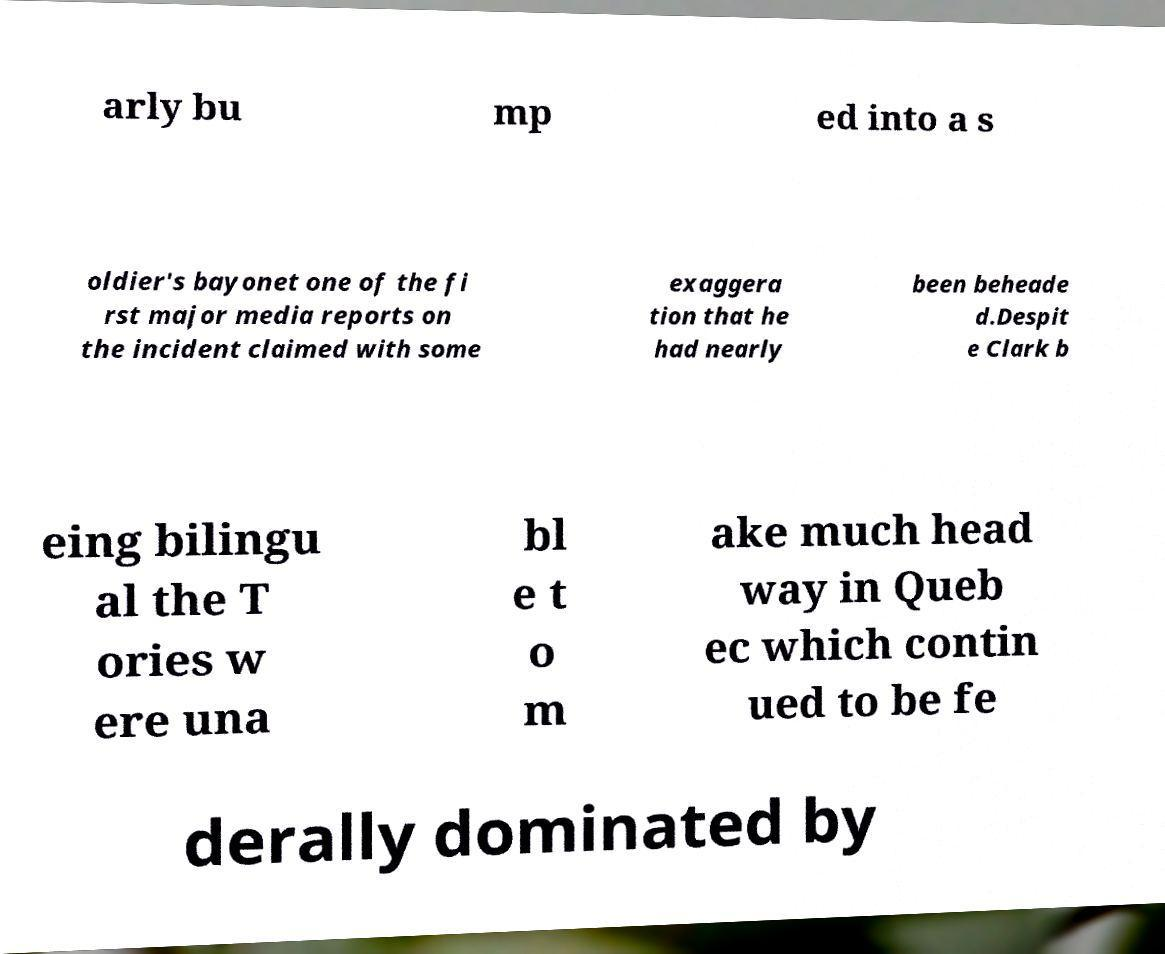Can you accurately transcribe the text from the provided image for me? arly bu mp ed into a s oldier's bayonet one of the fi rst major media reports on the incident claimed with some exaggera tion that he had nearly been beheade d.Despit e Clark b eing bilingu al the T ories w ere una bl e t o m ake much head way in Queb ec which contin ued to be fe derally dominated by 